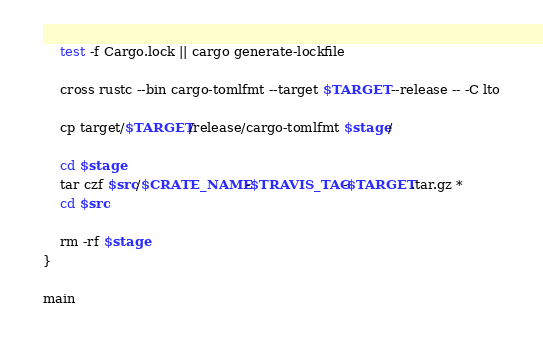Convert code to text. <code><loc_0><loc_0><loc_500><loc_500><_Bash_>    test -f Cargo.lock || cargo generate-lockfile

    cross rustc --bin cargo-tomlfmt --target $TARGET --release -- -C lto

    cp target/$TARGET/release/cargo-tomlfmt $stage/

    cd $stage
    tar czf $src/$CRATE_NAME-$TRAVIS_TAG-$TARGET.tar.gz *
    cd $src

    rm -rf $stage
}

main
</code> 